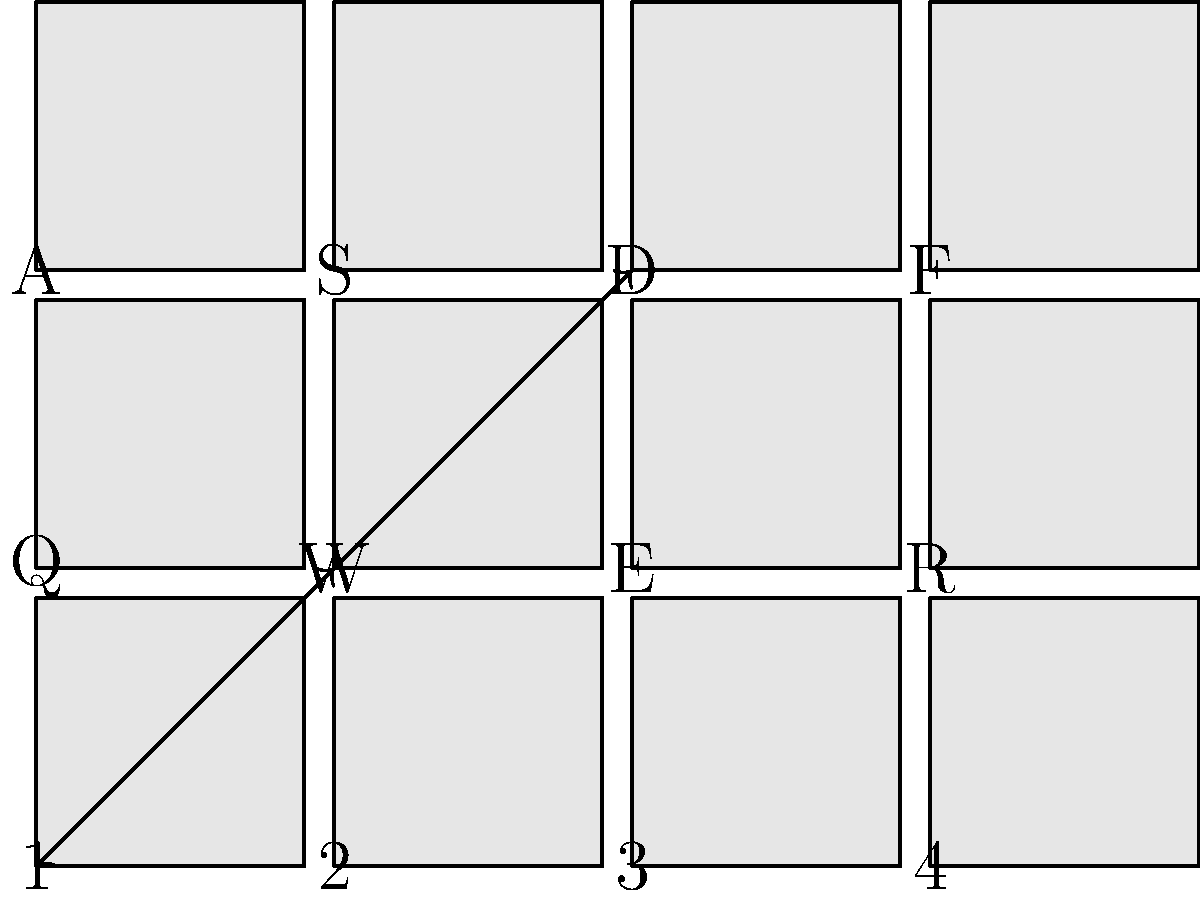As a keyboard customizer, you're working on a project to optimize the layout for a specific workflow. You decide to create a cyclic remapping of three keys: 1 → W → D → 1. How many different permutations (including the identity permutation) can be generated by repeatedly applying this remapping? Express your answer in terms of the order of the permutation group generated by this remapping. Let's approach this step-by-step:

1) First, we need to understand what the remapping does. It creates a cycle: 1 → W → D → 1.

2) In permutation notation, this can be written as (1 W D). This means 1 goes to W, W goes to D, and D goes back to 1.

3) To find all possible permutations, we need to apply this mapping repeatedly:
   - Initial state: (1)(W)(D) (identity permutation)
   - After one application: (1 W D)
   - After two applications: (1 D W)
   - After three applications: (1)(W)(D) (back to the identity)

4) We see that after three applications, we return to the initial state. This means the cycle has a length of 3.

5) In group theory, the number of elements in a cyclic group is equal to the length of the cycle that generates it.

6) Therefore, the order of the permutation group generated by this remapping is 3.

7) This means there are 3 different permutations possible (including the identity permutation).
Answer: 3 